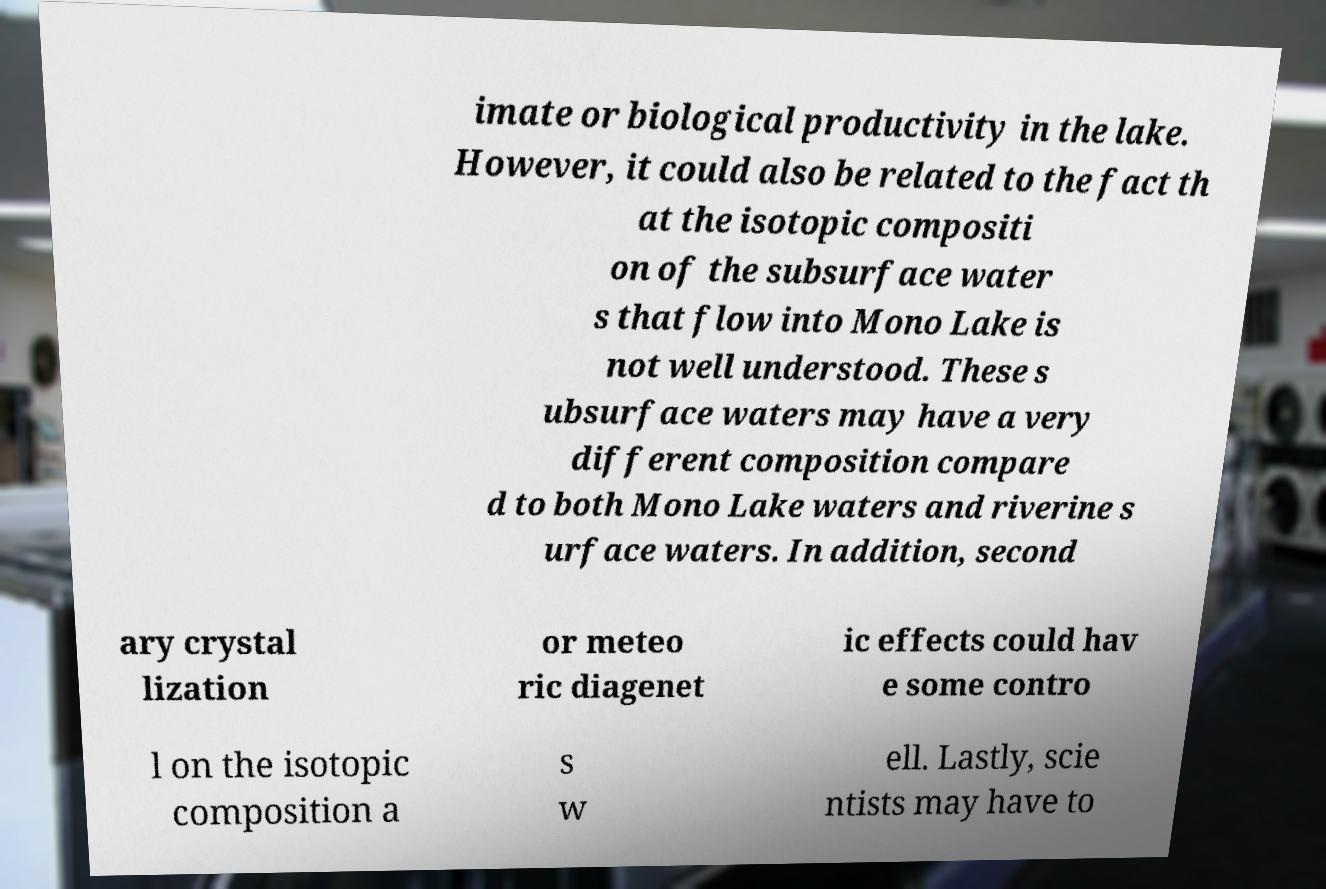I need the written content from this picture converted into text. Can you do that? imate or biological productivity in the lake. However, it could also be related to the fact th at the isotopic compositi on of the subsurface water s that flow into Mono Lake is not well understood. These s ubsurface waters may have a very different composition compare d to both Mono Lake waters and riverine s urface waters. In addition, second ary crystal lization or meteo ric diagenet ic effects could hav e some contro l on the isotopic composition a s w ell. Lastly, scie ntists may have to 